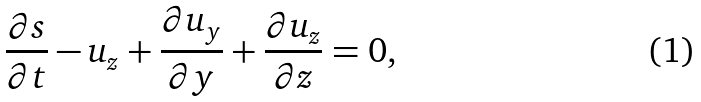<formula> <loc_0><loc_0><loc_500><loc_500>\frac { \partial s } { \partial t } - u _ { z } + \frac { \partial u _ { y } } { \partial y } + \frac { \partial u _ { z } } { \partial z } = 0 ,</formula> 